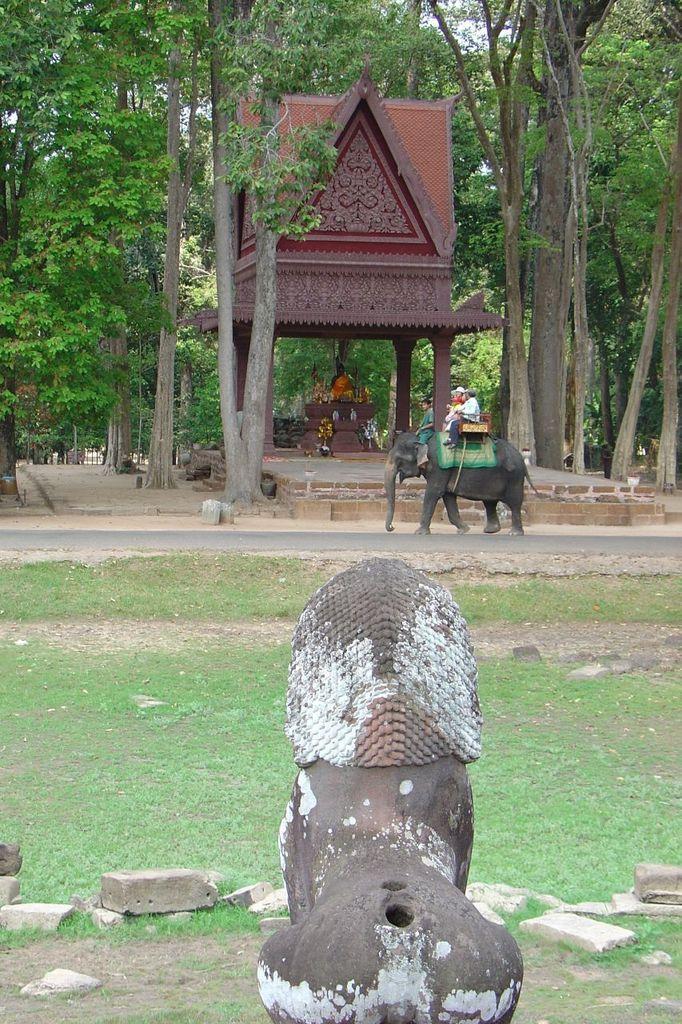How would you summarize this image in a sentence or two? In this image there is a statue at the bottom and there are two people sitting on an elephant behind it there is a temple which has a statue in it and is surrounded by trees 